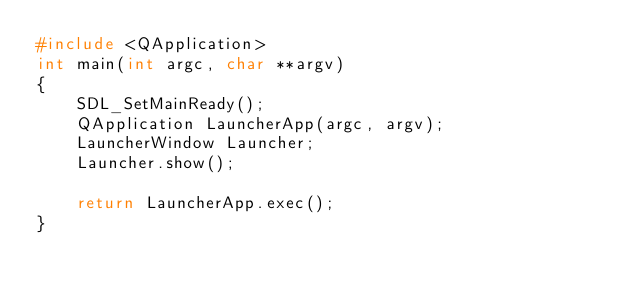<code> <loc_0><loc_0><loc_500><loc_500><_C++_>#include <QApplication>
int main(int argc, char **argv)
{
	SDL_SetMainReady();
	QApplication LauncherApp(argc, argv);
	LauncherWindow Launcher;
	Launcher.show();

	return LauncherApp.exec();
}
</code> 